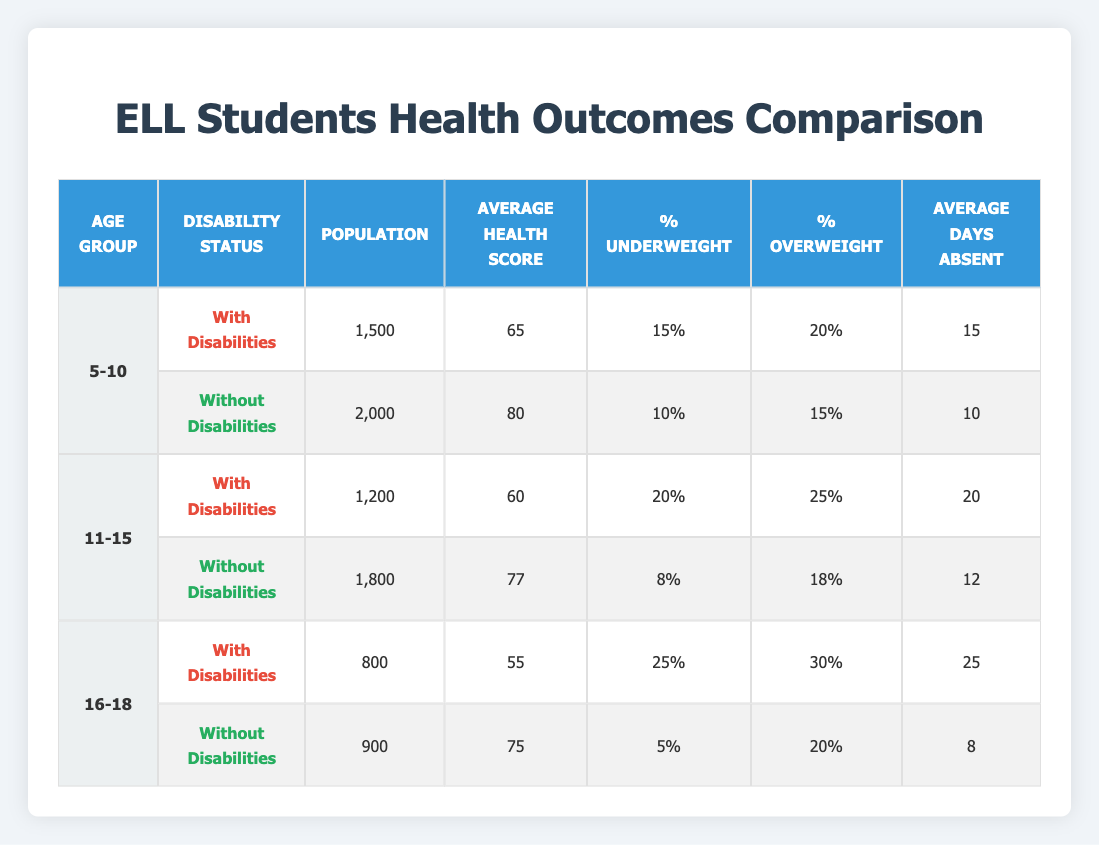What is the average health score for ELL students aged 5-10 with disabilities? The average health score for the age group 5-10 with disabilities is indicated in the table as 65.
Answer: 65 What percentage of ELL students aged 11-15 without disabilities are classified as underweight? The table shows that for the age group 11-15 without disabilities, the percentage underweight is 8%.
Answer: 8% How many average days absent do ELL students aged 16-18 with disabilities have compared to those without disabilities? The average days absent for the age group 16-18 with disabilities is 25 days, while without disabilities, it is 8 days. The difference is 25 - 8 = 17 days.
Answer: 17 days Is the percentage of overweight ELL students aged 5-10 with disabilities higher than those without disabilities? The percentage overweight for students aged 5-10 with disabilities is 20%, while for those without disabilities, it is 15%. Since 20% is greater than 15%, the statement is true.
Answer: Yes What is the average health score difference between ELL students aged 11-15 with disabilities and those without disabilities? The average health score for students aged 11-15 with disabilities is 60 and for those without disabilities is 77. The difference is 77 - 60 = 17 points.
Answer: 17 points How many total ELL students in the age group 16-18 have disabilities? The table shows that there are 800 ELL students aged 16-18 classified as with disabilities.
Answer: 800 What is the percentage of ELL students aged 5-10 who are considered overweight when they have disabilities? Based on the data, the percentage of ELL students aged 5-10 with disabilities classified as overweight is 20%.
Answer: 20% Do ELL students aged 11-15 with disabilities have a higher average health score than those aged 5-10 with disabilities? The average health score for students aged 11-15 with disabilities is 60, while for those aged 5-10 is 65. Since 60 is less than 65, this statement is false.
Answer: No What is the total population of ELL students aged 5-10 without disabilities? The data indicates that the total population for ELL students aged 5-10 without disabilities is 2000.
Answer: 2000 